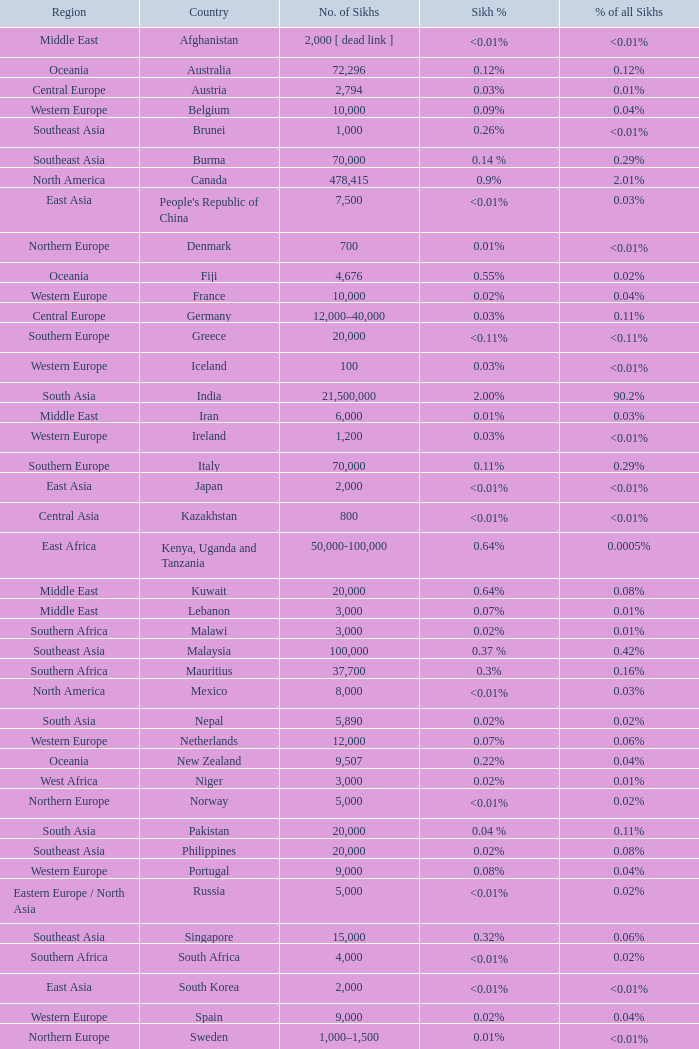In japan, what is the count of sikh individuals? 2000.0. 